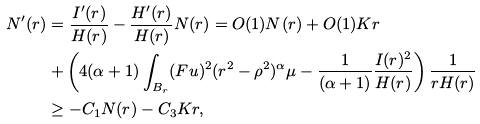<formula> <loc_0><loc_0><loc_500><loc_500>N ^ { \prime } ( r ) & = \frac { I ^ { \prime } ( r ) } { H ( r ) } - \frac { H ^ { \prime } ( r ) } { H ( r ) } N ( r ) = O ( 1 ) N ( r ) + O ( 1 ) K r \\ & + \left ( 4 ( \alpha + 1 ) \int _ { B _ { r } } ( F u ) ^ { 2 } ( r ^ { 2 } - \rho ^ { 2 } ) ^ { \alpha } \mu - \frac { 1 } { ( \alpha + 1 ) } \frac { I ( r ) ^ { 2 } } { H ( r ) } \right ) \frac { 1 } { r H ( r ) } \\ & \geq - C _ { 1 } N ( r ) - C _ { 3 } K r ,</formula> 